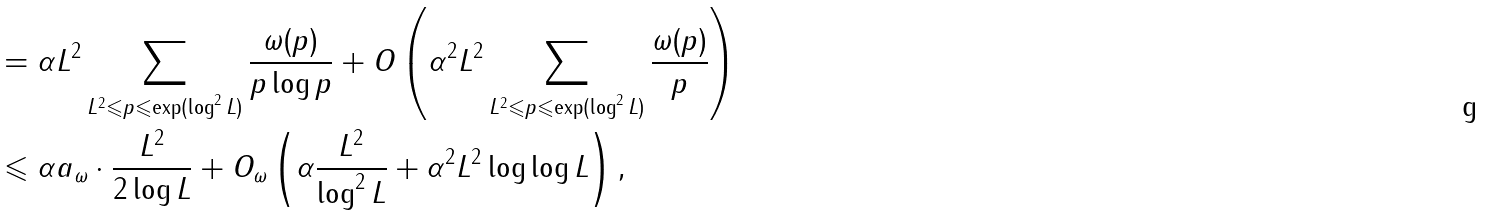Convert formula to latex. <formula><loc_0><loc_0><loc_500><loc_500>& = \alpha L ^ { 2 } \sum _ { L ^ { 2 } \leqslant p \leqslant \exp ( \log ^ { 2 } L ) } \frac { \omega ( p ) } { p \log p } + O \left ( \alpha ^ { 2 } L ^ { 2 } \sum _ { L ^ { 2 } \leqslant p \leqslant \exp ( \log ^ { 2 } L ) } \frac { \omega ( p ) } p \right ) \\ & \leqslant \alpha a _ { \omega } \cdot \frac { L ^ { 2 } } { 2 \log L } + O _ { \omega } \left ( \alpha \frac { L ^ { 2 } } { \log ^ { 2 } L } + \alpha ^ { 2 } L ^ { 2 } \log \log L \right ) ,</formula> 